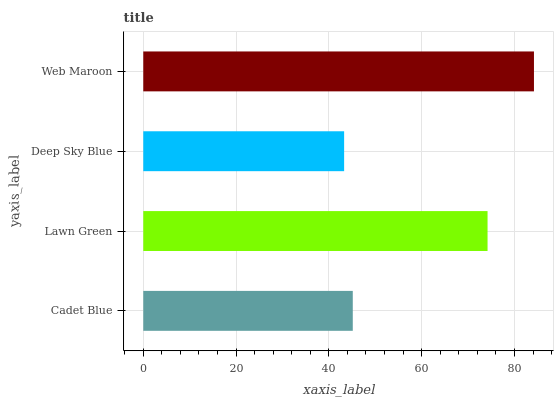Is Deep Sky Blue the minimum?
Answer yes or no. Yes. Is Web Maroon the maximum?
Answer yes or no. Yes. Is Lawn Green the minimum?
Answer yes or no. No. Is Lawn Green the maximum?
Answer yes or no. No. Is Lawn Green greater than Cadet Blue?
Answer yes or no. Yes. Is Cadet Blue less than Lawn Green?
Answer yes or no. Yes. Is Cadet Blue greater than Lawn Green?
Answer yes or no. No. Is Lawn Green less than Cadet Blue?
Answer yes or no. No. Is Lawn Green the high median?
Answer yes or no. Yes. Is Cadet Blue the low median?
Answer yes or no. Yes. Is Deep Sky Blue the high median?
Answer yes or no. No. Is Web Maroon the low median?
Answer yes or no. No. 